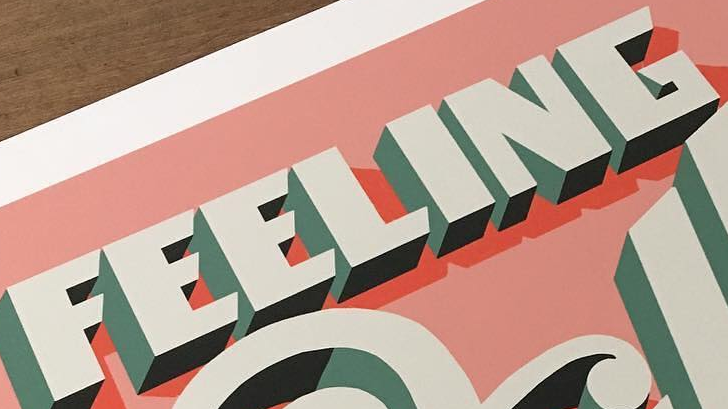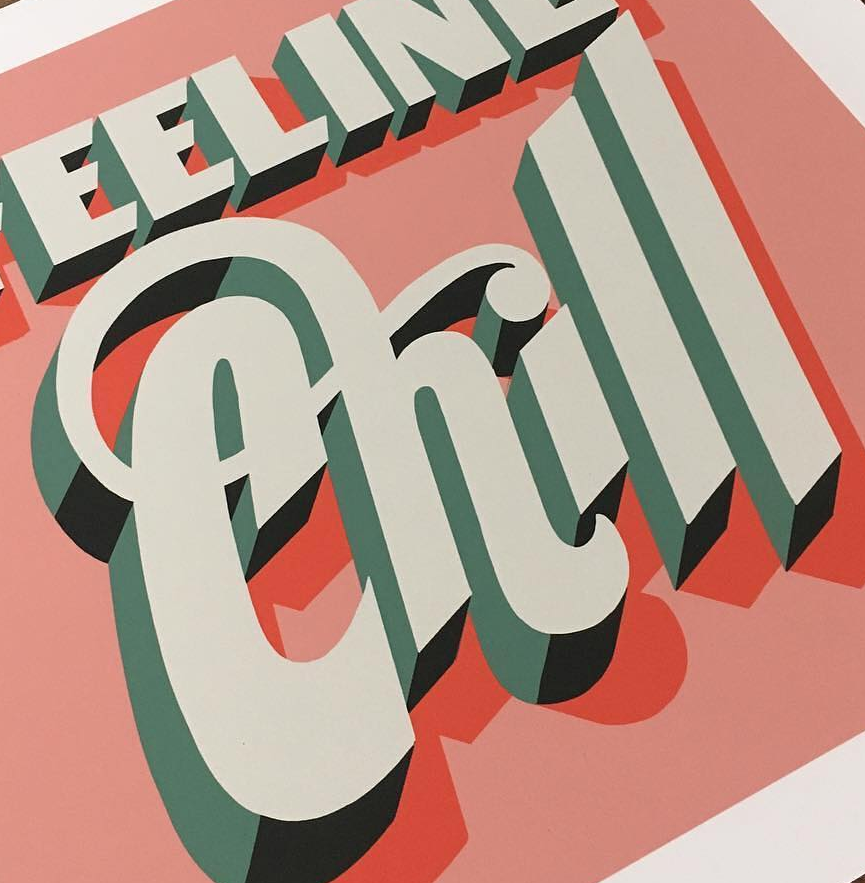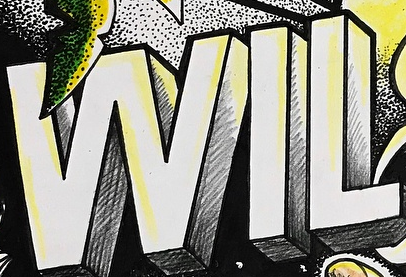Read the text from these images in sequence, separated by a semicolon. FEELING; Chill; WIL 